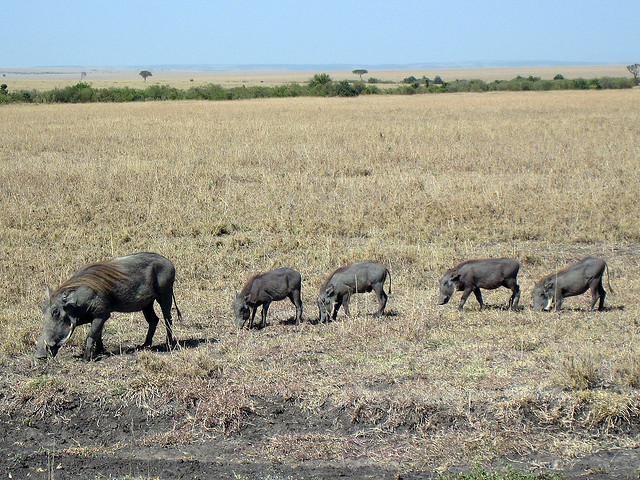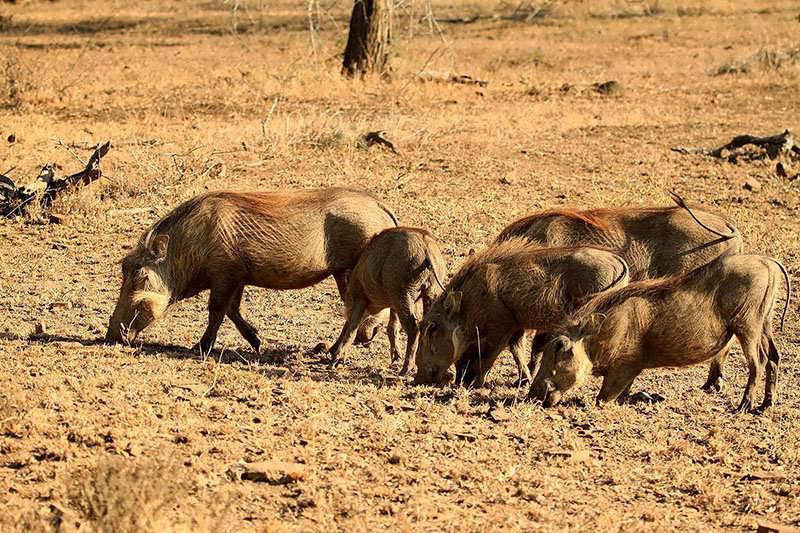The first image is the image on the left, the second image is the image on the right. For the images shown, is this caption "In one of the images there is a group of warthogs standing near water." true? Answer yes or no. No. The first image is the image on the left, the second image is the image on the right. For the images displayed, is the sentence "There are at least 5 black animals in th eimage on the left." factually correct? Answer yes or no. Yes. 